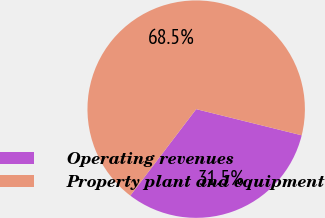Convert chart to OTSL. <chart><loc_0><loc_0><loc_500><loc_500><pie_chart><fcel>Operating revenues<fcel>Property plant and equipment<nl><fcel>31.49%<fcel>68.51%<nl></chart> 